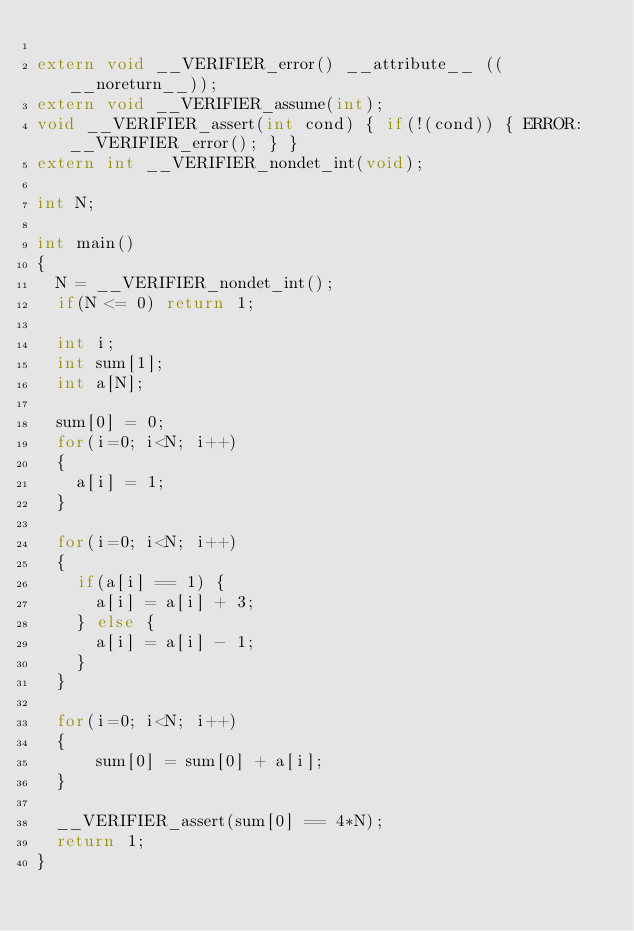Convert code to text. <code><loc_0><loc_0><loc_500><loc_500><_C_>
extern void __VERIFIER_error() __attribute__ ((__noreturn__));
extern void __VERIFIER_assume(int);
void __VERIFIER_assert(int cond) { if(!(cond)) { ERROR: __VERIFIER_error(); } }
extern int __VERIFIER_nondet_int(void);

int N;

int main()
{
	N = __VERIFIER_nondet_int();
	if(N <= 0) return 1;

	int i;
	int sum[1];
	int a[N];

	sum[0] = 0;
	for(i=0; i<N; i++)
	{
		a[i] = 1;
	}

	for(i=0; i<N; i++)
	{
		if(a[i] == 1) {
			a[i] = a[i] + 3;
		} else {
			a[i] = a[i] - 1;
		}
	}

	for(i=0; i<N; i++)
	{
			sum[0] = sum[0] + a[i];
	}

	__VERIFIER_assert(sum[0] == 4*N);
	return 1;
}
</code> 